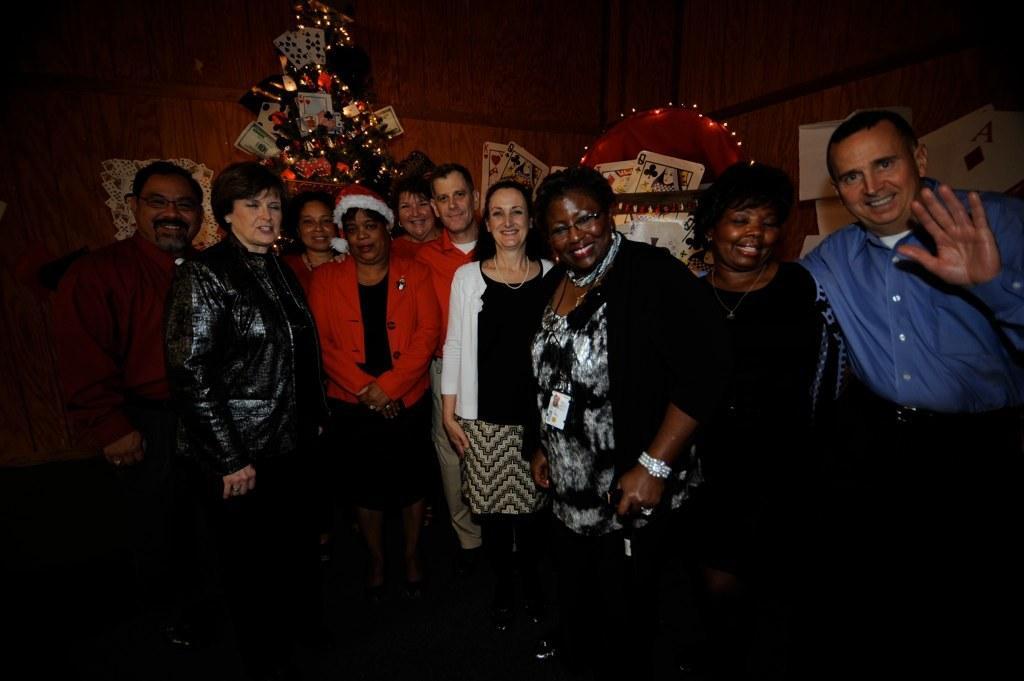Please provide a concise description of this image. In this picture we can see some persons standing and posing a camera. And these are the cards. And on the background there is a wall. 